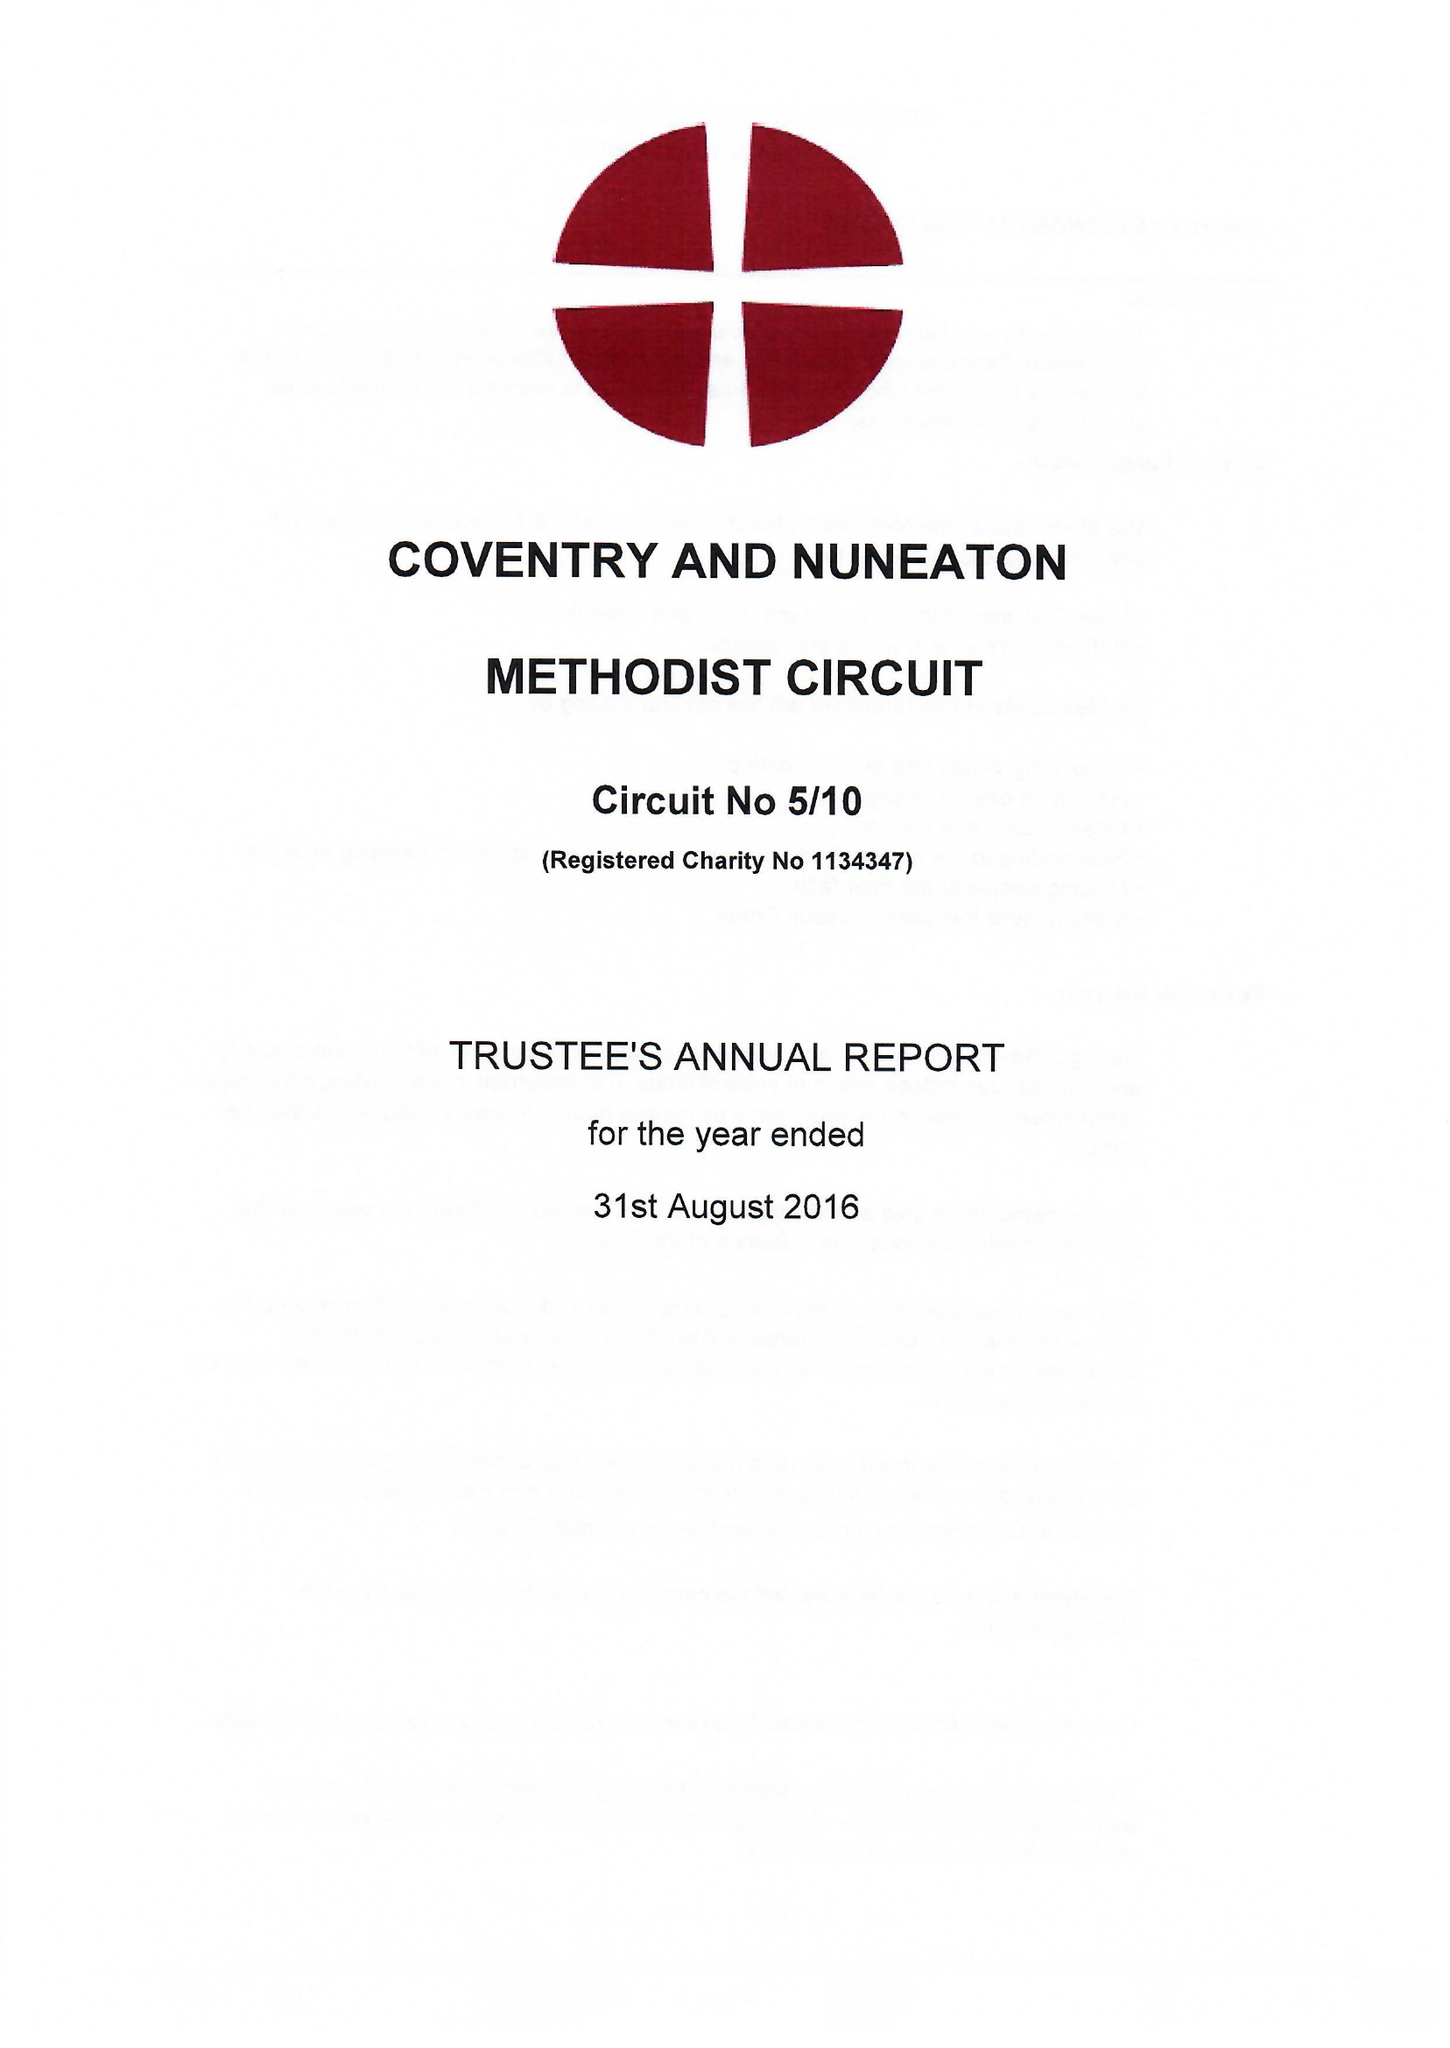What is the value for the charity_number?
Answer the question using a single word or phrase. 1134347 